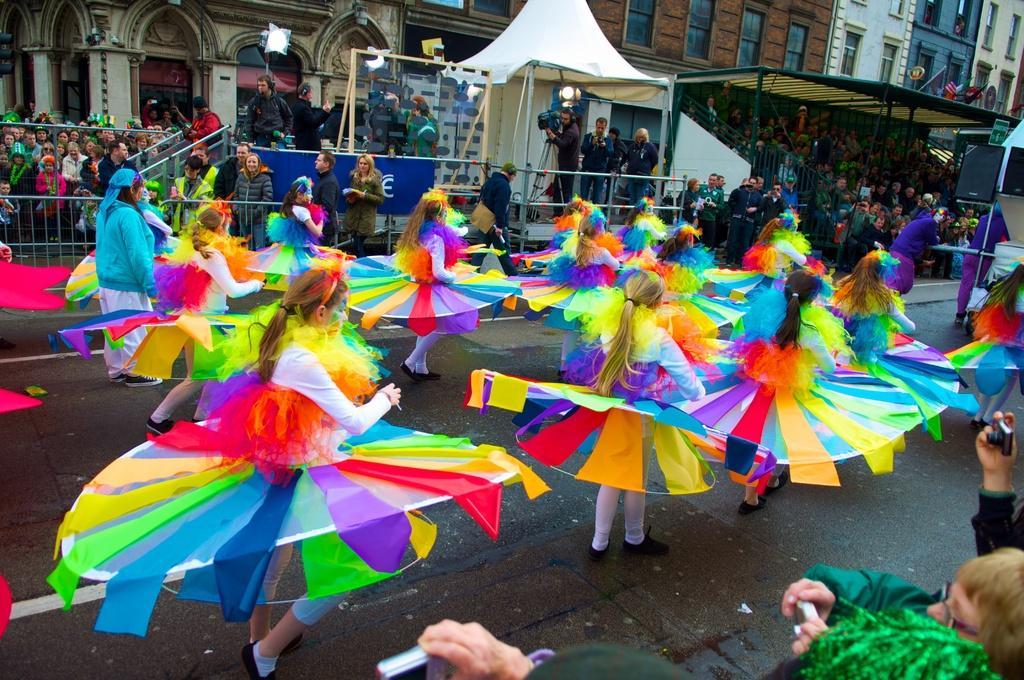In one or two sentences, can you explain what this image depicts? This picture consists of there are group of girls wearing colorful dresses standing on road and performing a dance , in the middle there are crowd of people on the left side in front of fence and some group of people visible under the tent on the right side and there is a camera and tent and lights visible in the middle ,at the bottom I can see there are few person taking the picture with camera. 